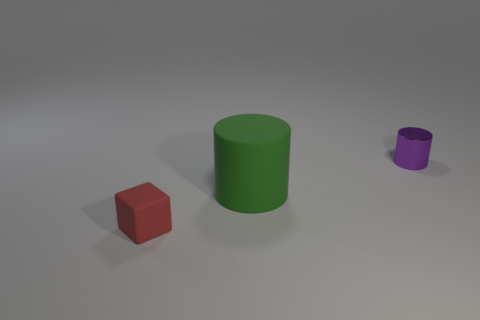Can you tell me the potential use of these objects if they were real physical items? If these objects were actual physical items, the red cube could serve as a simple paperweight or a child's toy block, given its shape and size. The green cylinder could be a container or a component of a modular construction system, given its hollow structure and circular opening. The purple cylinder, being smaller, could serve a decorative purpose or even function as a knob or handle for a piece of furniture or equipment due to its size and polished finish. 